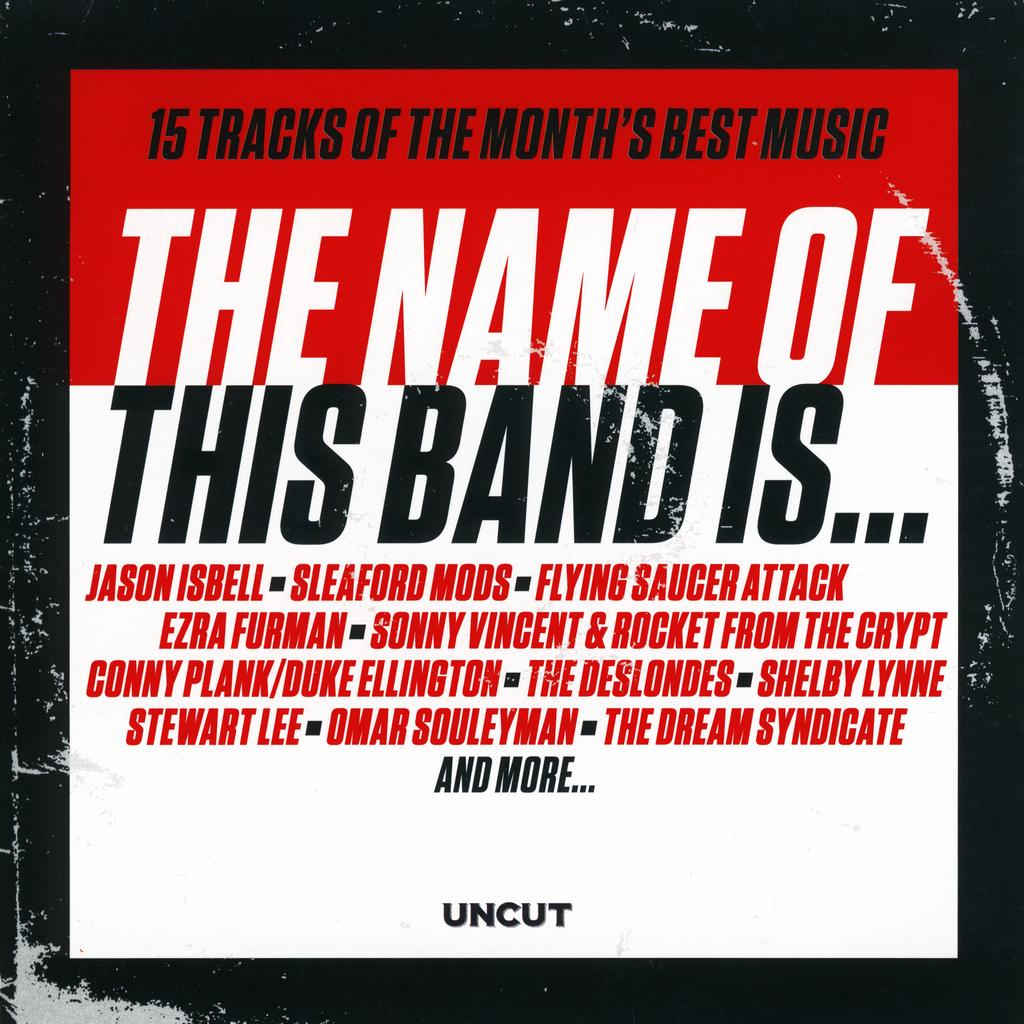<image>
Present a compact description of the photo's key features. 15 tracks of the month's best music uncut band 